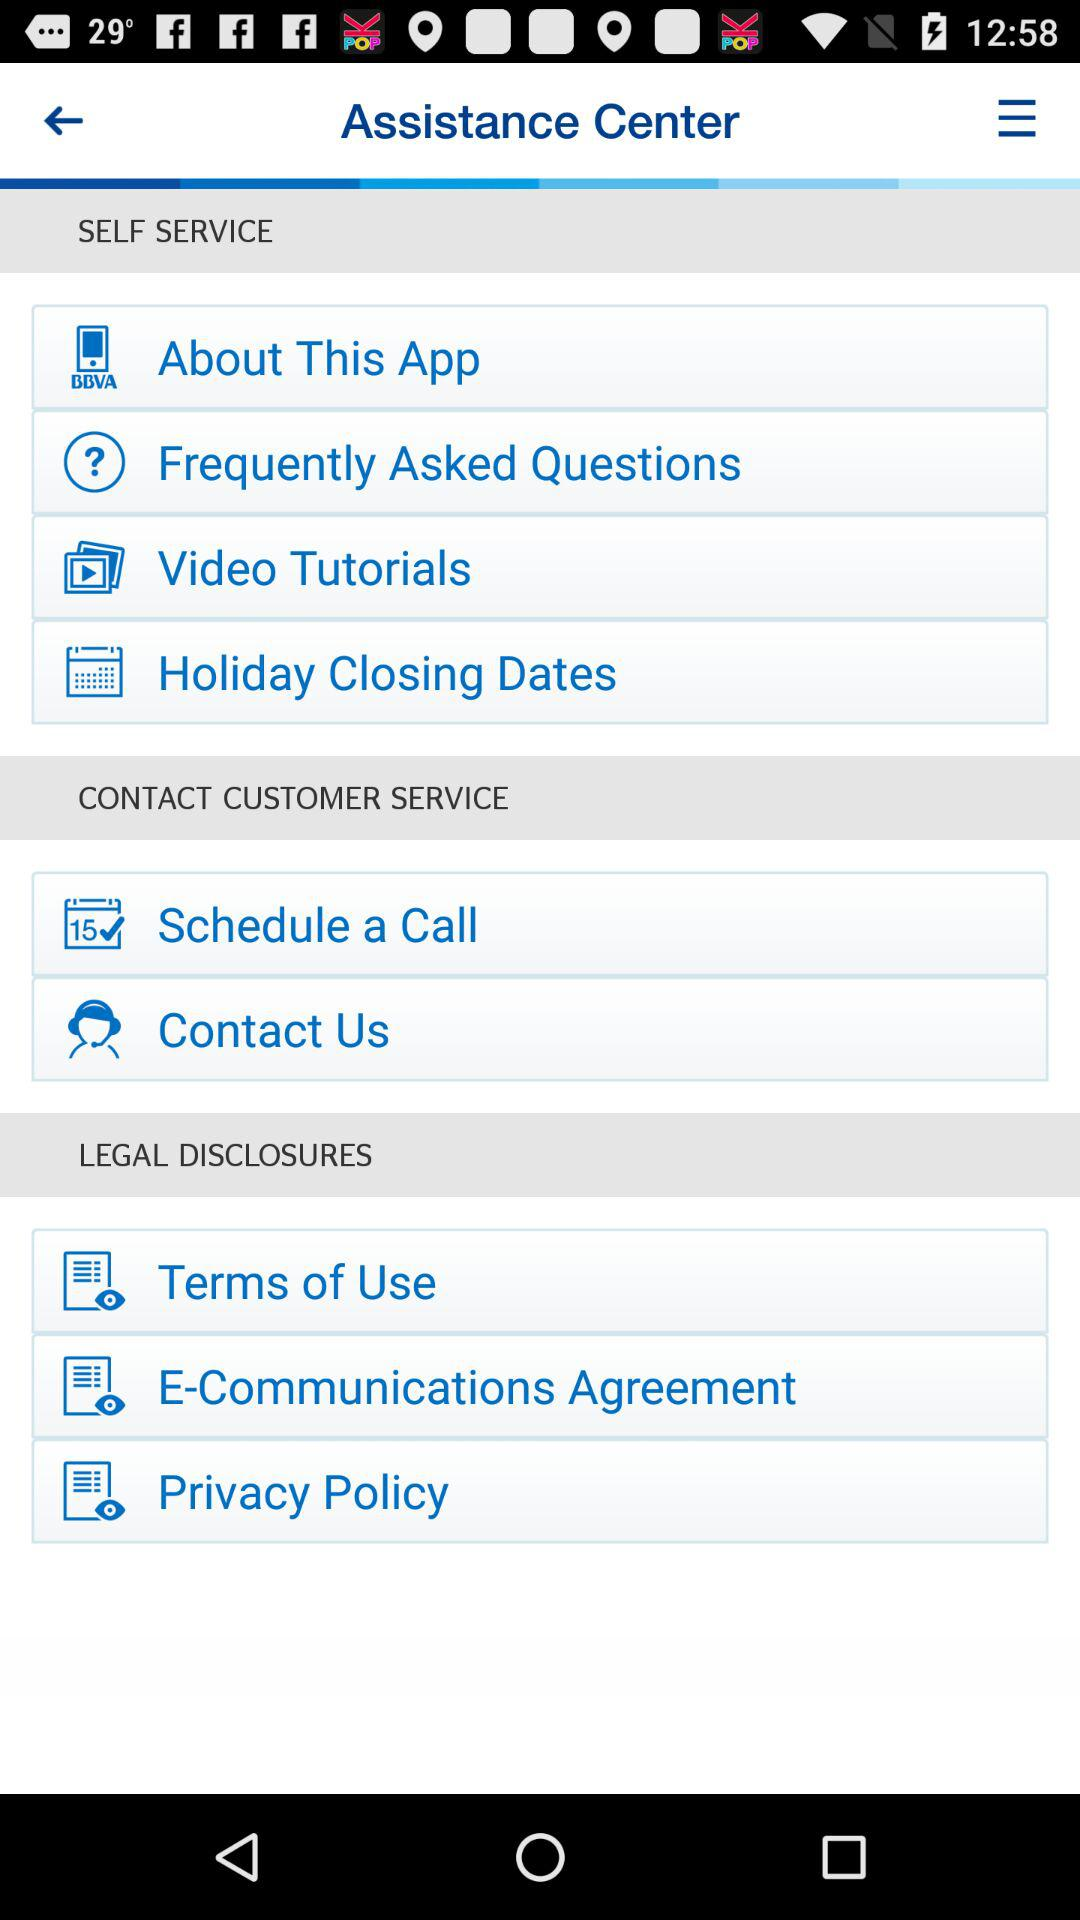What is the name of the application? The application name is "Assistance Center". 